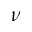Convert formula to latex. <formula><loc_0><loc_0><loc_500><loc_500>\nu</formula> 